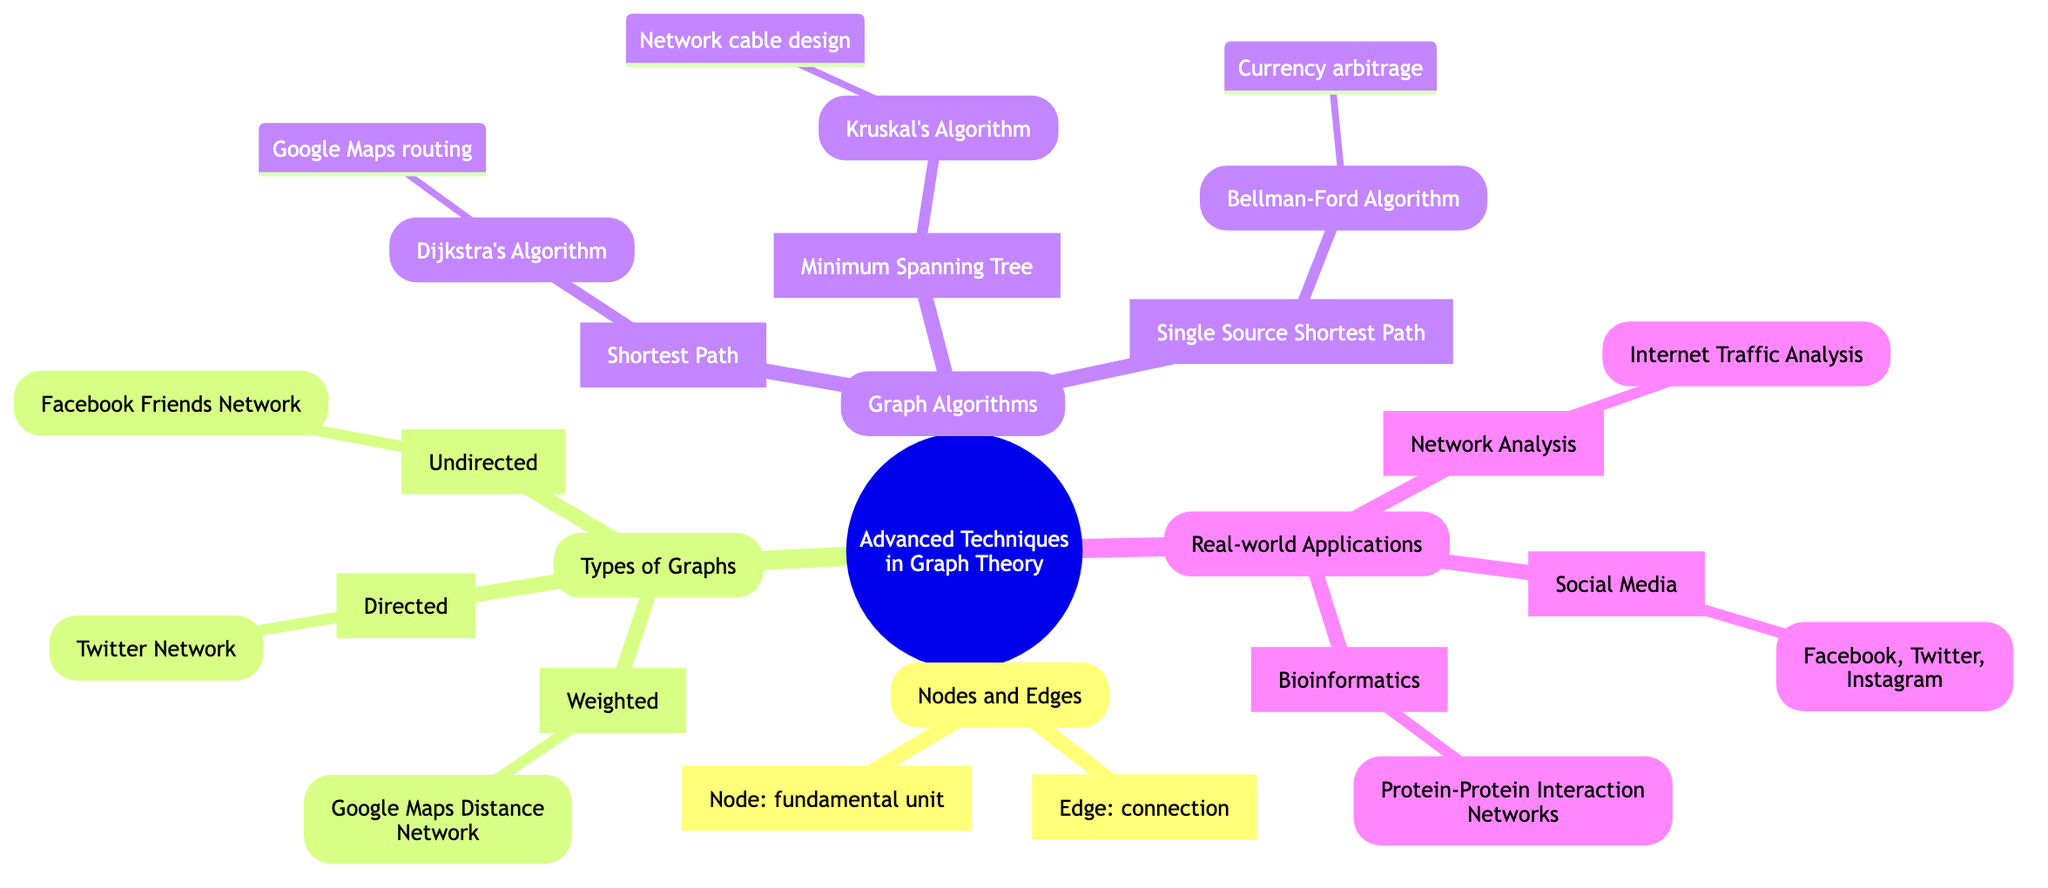What is a node? A node is defined in the diagram as a fundamental unit of which graphs are formed, representing entities.
Answer: fundamental unit What does an edge represent? The diagram states that an edge is a connection between a pair of nodes, representing relationships.
Answer: connection How many types of graphs are mentioned? The diagram lists three types of graphs: Undirected, Directed, and Weighted. This gives a total of three.
Answer: 3 What is an example of an undirected graph? According to the diagram, the example provided for an undirected graph is a Facebook Friends Network.
Answer: Facebook Friends Network Which algorithm is used for finding the shortest paths in a weighted graph? The diagram specifies that Dijkstra's Algorithm is used for finding the shortest paths from a source node to all other nodes in a weighted graph.
Answer: Dijkstra's Algorithm What is the primary use case for Kruskal's Algorithm? The diagram indicates that Kruskal's Algorithm is used in network design for minimizing cable length.
Answer: Network design for minimizing cable length What does the Bellman-Ford Algorithm evaluate? Based on the diagram, the Bellman-Ford Algorithm evaluates arbitrage opportunities in currency exchange markets.
Answer: Arbitrage opportunities What type of analysis is done in Bioinformatics according to this diagram? The diagram describes that Bioinformatics involves studying biological data through graph representations.
Answer: Studying biological data Which social media platforms are mentioned as part of social media applications? The diagram lists Facebook, Twitter, and Instagram as examples of social media platforms for analyzing interactions.
Answer: Facebook, Twitter, Instagram What is the example entity for network analysis? The diagram states that Internet Traffic Analysis is the example entity for network analysis in the real-world applications section.
Answer: Internet Traffic Analysis 